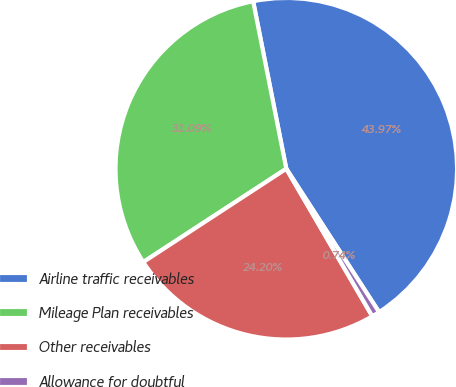Convert chart. <chart><loc_0><loc_0><loc_500><loc_500><pie_chart><fcel>Airline traffic receivables<fcel>Mileage Plan receivables<fcel>Other receivables<fcel>Allowance for doubtful<nl><fcel>43.97%<fcel>31.09%<fcel>24.2%<fcel>0.74%<nl></chart> 